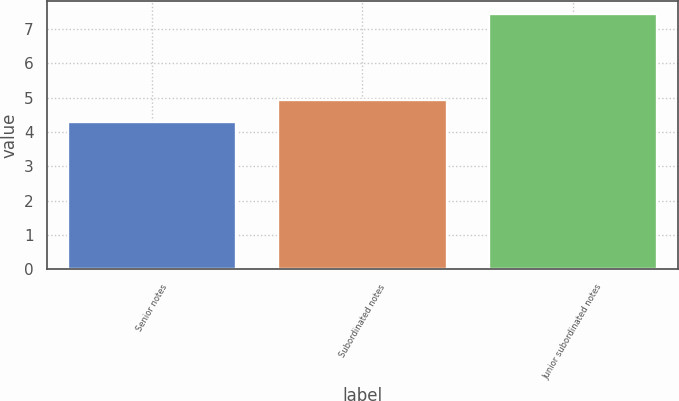Convert chart to OTSL. <chart><loc_0><loc_0><loc_500><loc_500><bar_chart><fcel>Senior notes<fcel>Subordinated notes<fcel>Junior subordinated notes<nl><fcel>4.3<fcel>4.92<fcel>7.44<nl></chart> 